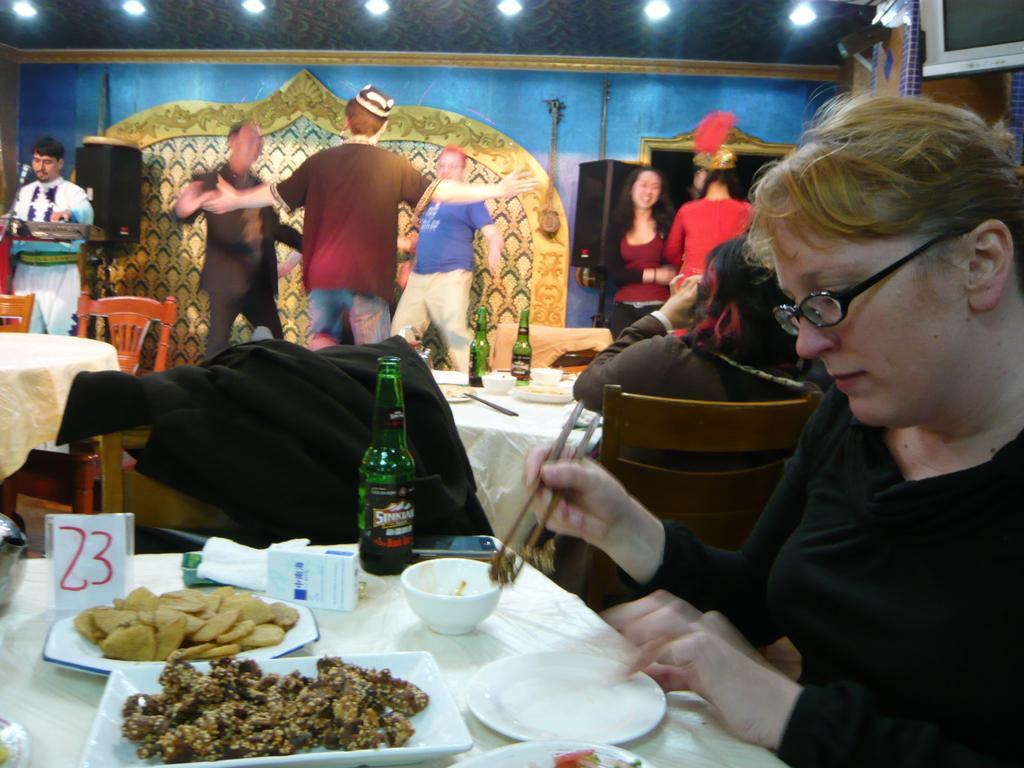Can you describe this image briefly? In the image on the right we can see one woman sitting and she is holding chopsticks. In front of her,we can see one table. On table,we can see cloth,plates,papers,bowl,bottle,some food items and few other objects. In the background we can see wall,lights,tablecloths,chairs,wine bottles,one person sitting,few people were standing and few other objects. 